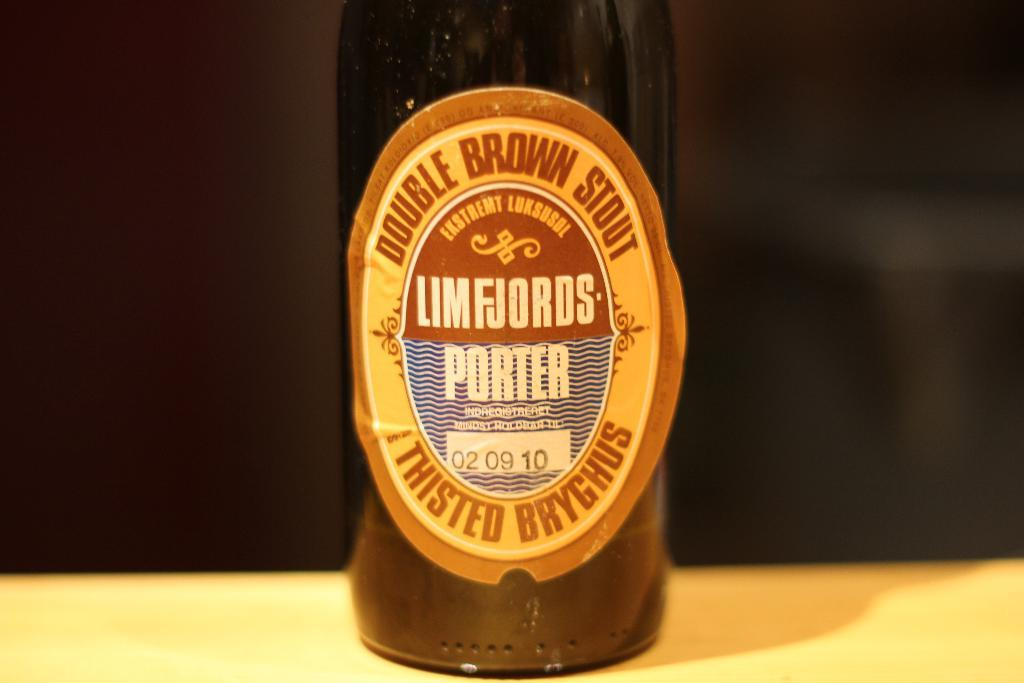Provide a one-sentence caption for the provided image. A bottle of Limfjords Porter Stout Ale sits on a table. 